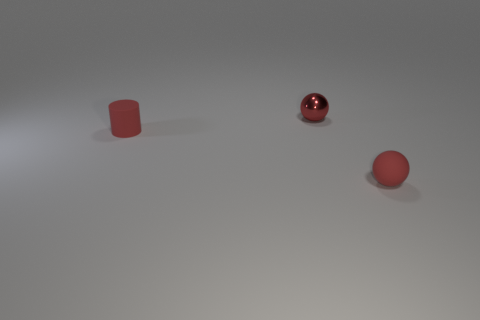Is there any other thing that is the same color as the small cylinder?
Ensure brevity in your answer.  Yes. There is a matte thing that is the same color as the rubber ball; what shape is it?
Keep it short and to the point. Cylinder. What is the material of the small thing in front of the matte cylinder?
Provide a succinct answer. Rubber. What material is the red thing that is right of the matte cylinder and behind the rubber sphere?
Make the answer very short. Metal. Does the red ball in front of the red matte cylinder have the same size as the tiny red metal object?
Provide a short and direct response. Yes. The red metallic object has what shape?
Give a very brief answer. Sphere. How many brown metallic things have the same shape as the red metallic thing?
Ensure brevity in your answer.  0. What number of red spheres are both in front of the cylinder and behind the tiny rubber cylinder?
Provide a short and direct response. 0. The small matte sphere has what color?
Offer a terse response. Red. Are there any tiny red objects made of the same material as the small cylinder?
Offer a terse response. Yes. 